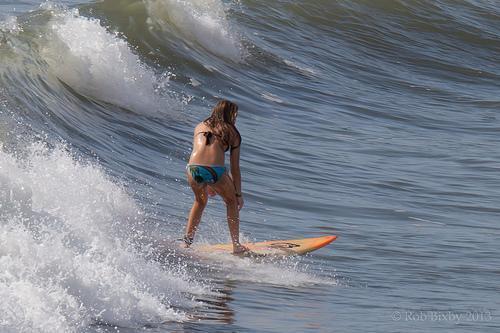How many surfers can be seen?
Give a very brief answer. 1. 